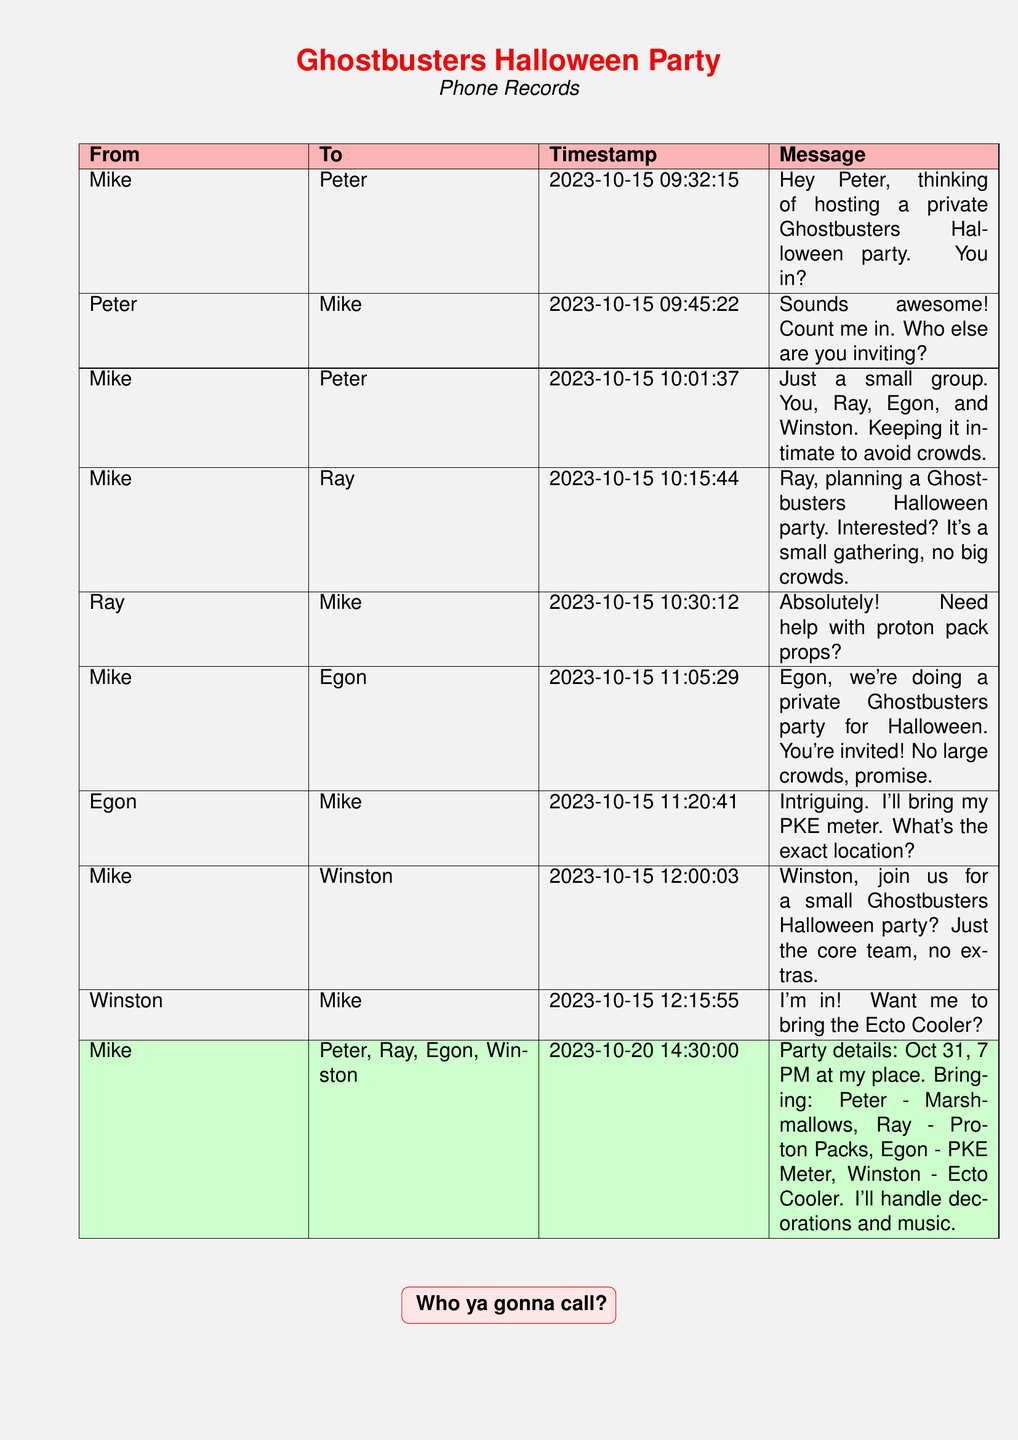What is the date of the party? The date of the party is found in the message about the party details, which states October 31.
Answer: October 31 Who is hosting the party? The host of the party can be found in the first message sent. It indicates that Mike is hosting the party.
Answer: Mike What time does the party start? The time of the party is stated in the message about party details, which indicates the start time is 7 PM.
Answer: 7 PM Which item will Ray bring? The item that Ray is bringing to the party is listed in the party details message, which states Proton Packs.
Answer: Proton Packs How many people are invited to the party? The number of people can be inferred from the messages as it mentions only four core members in addition to Mike.
Answer: Four What did Winston offer to bring? Winston's offer to bring a specific item can be found in his text message, which mentions Ecto Cooler.
Answer: Ecto Cooler What did Mike plan for decorations? The document indicates that Mike would handle decorations in the party details message, which directly answers this query.
Answer: Decorations Who responded first about party interest? The first person to respond about being interested in the party is Peter, as shown in the second message.
Answer: Peter What will Egon bring? Egon's contribution is specified in the details message, indicating that he will bring a PKE Meter.
Answer: PKE Meter 